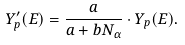Convert formula to latex. <formula><loc_0><loc_0><loc_500><loc_500>Y ^ { \prime } _ { p } ( E ) = \frac { a } { a + b N _ { \alpha } } \cdot Y _ { p } ( E ) .</formula> 